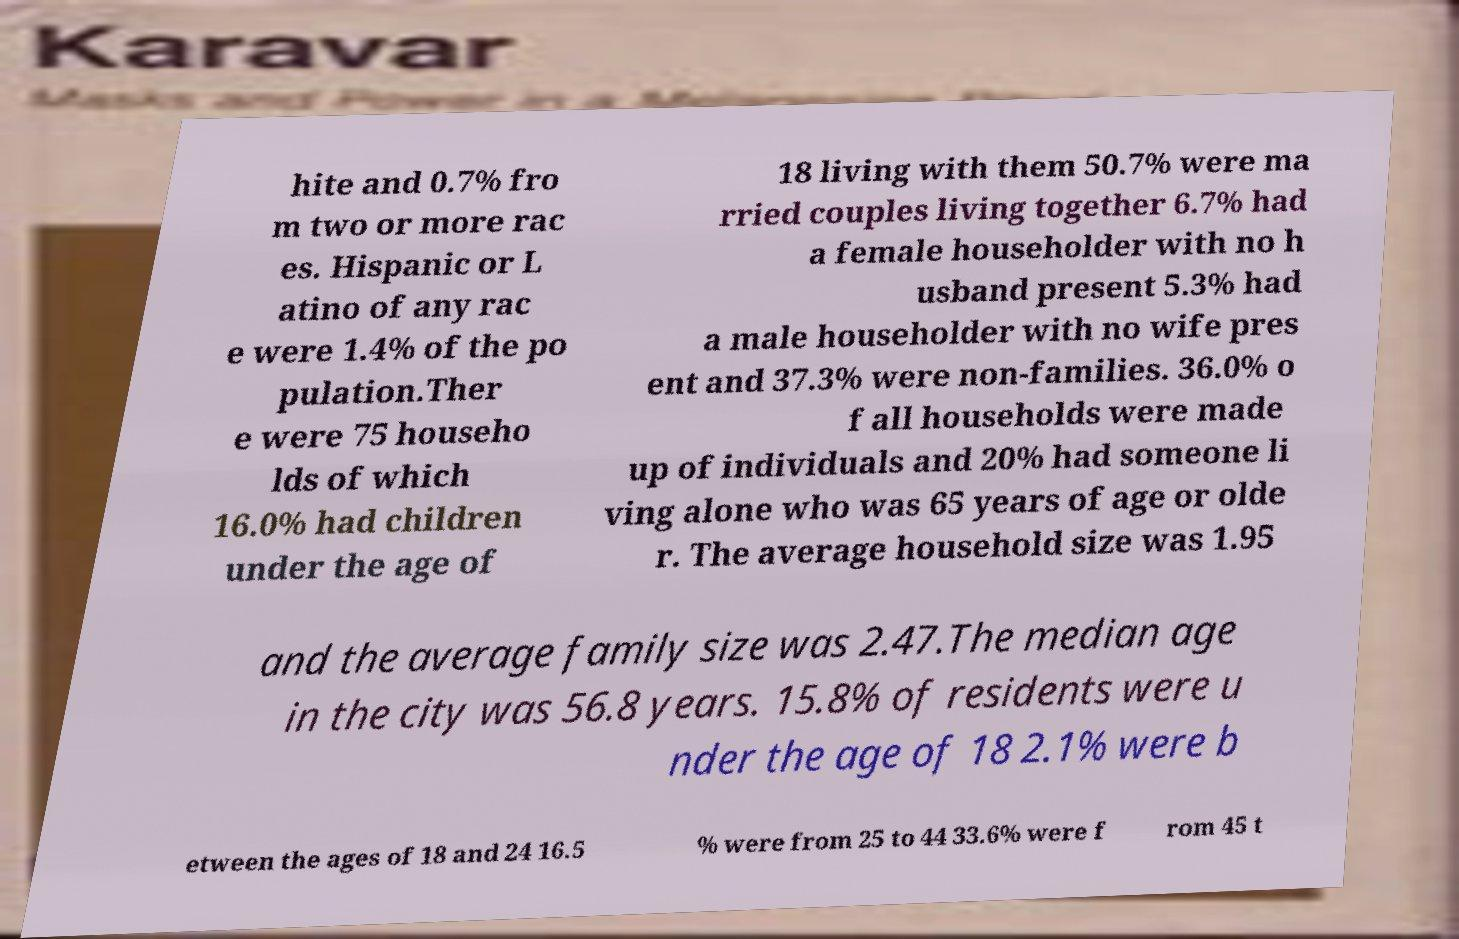Could you extract and type out the text from this image? hite and 0.7% fro m two or more rac es. Hispanic or L atino of any rac e were 1.4% of the po pulation.Ther e were 75 househo lds of which 16.0% had children under the age of 18 living with them 50.7% were ma rried couples living together 6.7% had a female householder with no h usband present 5.3% had a male householder with no wife pres ent and 37.3% were non-families. 36.0% o f all households were made up of individuals and 20% had someone li ving alone who was 65 years of age or olde r. The average household size was 1.95 and the average family size was 2.47.The median age in the city was 56.8 years. 15.8% of residents were u nder the age of 18 2.1% were b etween the ages of 18 and 24 16.5 % were from 25 to 44 33.6% were f rom 45 t 